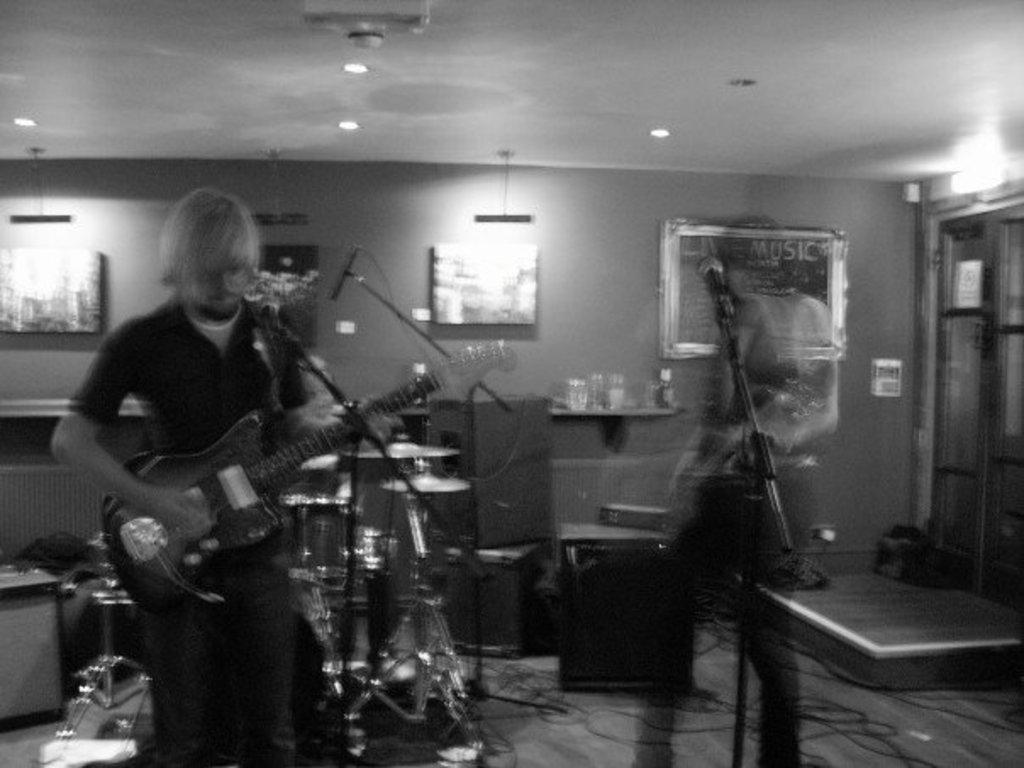In one or two sentences, can you explain what this image depicts? In this image their is a man who is standing and playing the guitar with his hand, there is mic in front of him. At the background there are drums and musical plates beside the man there is another person who is standing in front of the mic. At the back side there are photo frames and glasses. At the bottom there are speakers. At the right top corner there's a light. 